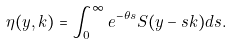<formula> <loc_0><loc_0><loc_500><loc_500>\eta ( y , k ) = \int _ { 0 } ^ { \infty } e ^ { - \theta s } S ( y - s k ) d s .</formula> 